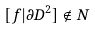<formula> <loc_0><loc_0><loc_500><loc_500>[ f | \partial D ^ { 2 } ] \notin N</formula> 